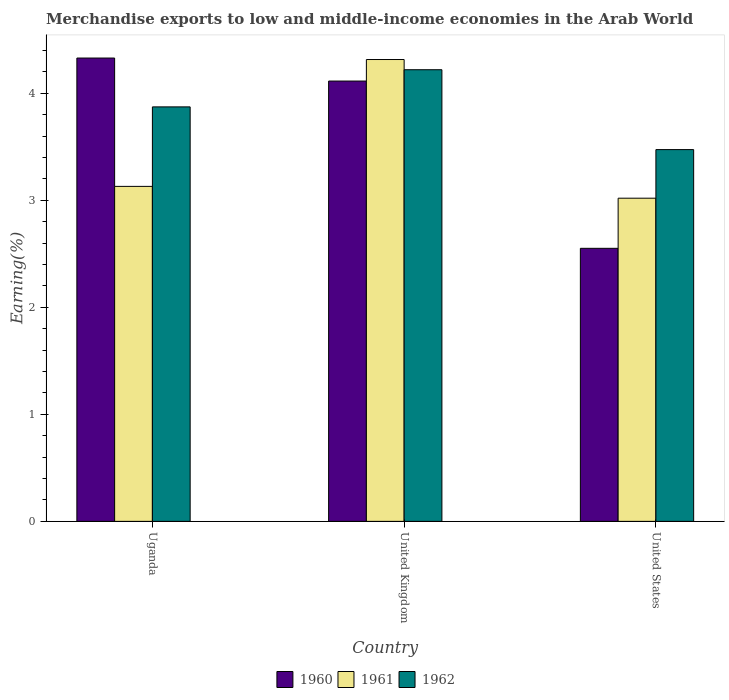How many groups of bars are there?
Give a very brief answer. 3. Are the number of bars per tick equal to the number of legend labels?
Your answer should be very brief. Yes. Are the number of bars on each tick of the X-axis equal?
Your response must be concise. Yes. How many bars are there on the 1st tick from the right?
Provide a succinct answer. 3. What is the label of the 1st group of bars from the left?
Offer a terse response. Uganda. What is the percentage of amount earned from merchandise exports in 1962 in United Kingdom?
Your answer should be compact. 4.22. Across all countries, what is the maximum percentage of amount earned from merchandise exports in 1962?
Ensure brevity in your answer.  4.22. Across all countries, what is the minimum percentage of amount earned from merchandise exports in 1962?
Give a very brief answer. 3.47. In which country was the percentage of amount earned from merchandise exports in 1960 minimum?
Your answer should be compact. United States. What is the total percentage of amount earned from merchandise exports in 1961 in the graph?
Ensure brevity in your answer.  10.47. What is the difference between the percentage of amount earned from merchandise exports in 1961 in Uganda and that in United Kingdom?
Ensure brevity in your answer.  -1.19. What is the difference between the percentage of amount earned from merchandise exports in 1961 in United States and the percentage of amount earned from merchandise exports in 1960 in United Kingdom?
Offer a very short reply. -1.09. What is the average percentage of amount earned from merchandise exports in 1961 per country?
Provide a short and direct response. 3.49. What is the difference between the percentage of amount earned from merchandise exports of/in 1962 and percentage of amount earned from merchandise exports of/in 1960 in United Kingdom?
Your response must be concise. 0.11. In how many countries, is the percentage of amount earned from merchandise exports in 1962 greater than 4.2 %?
Offer a very short reply. 1. What is the ratio of the percentage of amount earned from merchandise exports in 1962 in Uganda to that in United Kingdom?
Your answer should be very brief. 0.92. Is the percentage of amount earned from merchandise exports in 1962 in United Kingdom less than that in United States?
Keep it short and to the point. No. What is the difference between the highest and the second highest percentage of amount earned from merchandise exports in 1961?
Keep it short and to the point. -0.11. What is the difference between the highest and the lowest percentage of amount earned from merchandise exports in 1961?
Make the answer very short. 1.3. In how many countries, is the percentage of amount earned from merchandise exports in 1962 greater than the average percentage of amount earned from merchandise exports in 1962 taken over all countries?
Your response must be concise. 2. What does the 1st bar from the left in United Kingdom represents?
Your answer should be very brief. 1960. How many bars are there?
Your response must be concise. 9. Are all the bars in the graph horizontal?
Your answer should be very brief. No. How many countries are there in the graph?
Provide a short and direct response. 3. What is the difference between two consecutive major ticks on the Y-axis?
Give a very brief answer. 1. Are the values on the major ticks of Y-axis written in scientific E-notation?
Make the answer very short. No. How are the legend labels stacked?
Ensure brevity in your answer.  Horizontal. What is the title of the graph?
Offer a terse response. Merchandise exports to low and middle-income economies in the Arab World. Does "2000" appear as one of the legend labels in the graph?
Your answer should be compact. No. What is the label or title of the Y-axis?
Offer a terse response. Earning(%). What is the Earning(%) of 1960 in Uganda?
Offer a terse response. 4.33. What is the Earning(%) in 1961 in Uganda?
Keep it short and to the point. 3.13. What is the Earning(%) of 1962 in Uganda?
Keep it short and to the point. 3.87. What is the Earning(%) in 1960 in United Kingdom?
Offer a very short reply. 4.11. What is the Earning(%) in 1961 in United Kingdom?
Offer a terse response. 4.32. What is the Earning(%) in 1962 in United Kingdom?
Offer a terse response. 4.22. What is the Earning(%) in 1960 in United States?
Your answer should be compact. 2.55. What is the Earning(%) of 1961 in United States?
Offer a very short reply. 3.02. What is the Earning(%) of 1962 in United States?
Make the answer very short. 3.47. Across all countries, what is the maximum Earning(%) of 1960?
Give a very brief answer. 4.33. Across all countries, what is the maximum Earning(%) in 1961?
Make the answer very short. 4.32. Across all countries, what is the maximum Earning(%) in 1962?
Give a very brief answer. 4.22. Across all countries, what is the minimum Earning(%) in 1960?
Provide a succinct answer. 2.55. Across all countries, what is the minimum Earning(%) in 1961?
Offer a terse response. 3.02. Across all countries, what is the minimum Earning(%) of 1962?
Your answer should be compact. 3.47. What is the total Earning(%) of 1960 in the graph?
Your response must be concise. 11. What is the total Earning(%) in 1961 in the graph?
Make the answer very short. 10.47. What is the total Earning(%) in 1962 in the graph?
Ensure brevity in your answer.  11.57. What is the difference between the Earning(%) of 1960 in Uganda and that in United Kingdom?
Ensure brevity in your answer.  0.21. What is the difference between the Earning(%) of 1961 in Uganda and that in United Kingdom?
Offer a terse response. -1.19. What is the difference between the Earning(%) in 1962 in Uganda and that in United Kingdom?
Provide a short and direct response. -0.35. What is the difference between the Earning(%) in 1960 in Uganda and that in United States?
Your answer should be very brief. 1.78. What is the difference between the Earning(%) in 1961 in Uganda and that in United States?
Keep it short and to the point. 0.11. What is the difference between the Earning(%) in 1962 in Uganda and that in United States?
Keep it short and to the point. 0.4. What is the difference between the Earning(%) of 1960 in United Kingdom and that in United States?
Give a very brief answer. 1.56. What is the difference between the Earning(%) in 1961 in United Kingdom and that in United States?
Keep it short and to the point. 1.3. What is the difference between the Earning(%) in 1962 in United Kingdom and that in United States?
Provide a short and direct response. 0.75. What is the difference between the Earning(%) of 1960 in Uganda and the Earning(%) of 1961 in United Kingdom?
Your answer should be compact. 0.01. What is the difference between the Earning(%) of 1960 in Uganda and the Earning(%) of 1962 in United Kingdom?
Give a very brief answer. 0.11. What is the difference between the Earning(%) of 1961 in Uganda and the Earning(%) of 1962 in United Kingdom?
Provide a short and direct response. -1.09. What is the difference between the Earning(%) in 1960 in Uganda and the Earning(%) in 1961 in United States?
Provide a short and direct response. 1.31. What is the difference between the Earning(%) in 1960 in Uganda and the Earning(%) in 1962 in United States?
Ensure brevity in your answer.  0.86. What is the difference between the Earning(%) in 1961 in Uganda and the Earning(%) in 1962 in United States?
Offer a very short reply. -0.34. What is the difference between the Earning(%) of 1960 in United Kingdom and the Earning(%) of 1961 in United States?
Offer a terse response. 1.09. What is the difference between the Earning(%) of 1960 in United Kingdom and the Earning(%) of 1962 in United States?
Ensure brevity in your answer.  0.64. What is the difference between the Earning(%) in 1961 in United Kingdom and the Earning(%) in 1962 in United States?
Keep it short and to the point. 0.84. What is the average Earning(%) in 1960 per country?
Provide a short and direct response. 3.67. What is the average Earning(%) in 1961 per country?
Offer a very short reply. 3.49. What is the average Earning(%) in 1962 per country?
Offer a terse response. 3.86. What is the difference between the Earning(%) in 1960 and Earning(%) in 1961 in Uganda?
Your answer should be very brief. 1.2. What is the difference between the Earning(%) of 1960 and Earning(%) of 1962 in Uganda?
Provide a short and direct response. 0.46. What is the difference between the Earning(%) of 1961 and Earning(%) of 1962 in Uganda?
Your answer should be very brief. -0.74. What is the difference between the Earning(%) of 1960 and Earning(%) of 1961 in United Kingdom?
Give a very brief answer. -0.2. What is the difference between the Earning(%) in 1960 and Earning(%) in 1962 in United Kingdom?
Your answer should be very brief. -0.11. What is the difference between the Earning(%) in 1961 and Earning(%) in 1962 in United Kingdom?
Provide a short and direct response. 0.1. What is the difference between the Earning(%) in 1960 and Earning(%) in 1961 in United States?
Your answer should be very brief. -0.47. What is the difference between the Earning(%) in 1960 and Earning(%) in 1962 in United States?
Keep it short and to the point. -0.92. What is the difference between the Earning(%) in 1961 and Earning(%) in 1962 in United States?
Keep it short and to the point. -0.45. What is the ratio of the Earning(%) of 1960 in Uganda to that in United Kingdom?
Ensure brevity in your answer.  1.05. What is the ratio of the Earning(%) of 1961 in Uganda to that in United Kingdom?
Offer a very short reply. 0.73. What is the ratio of the Earning(%) in 1962 in Uganda to that in United Kingdom?
Your answer should be very brief. 0.92. What is the ratio of the Earning(%) of 1960 in Uganda to that in United States?
Provide a short and direct response. 1.7. What is the ratio of the Earning(%) of 1961 in Uganda to that in United States?
Offer a very short reply. 1.04. What is the ratio of the Earning(%) of 1962 in Uganda to that in United States?
Your answer should be compact. 1.11. What is the ratio of the Earning(%) of 1960 in United Kingdom to that in United States?
Your answer should be very brief. 1.61. What is the ratio of the Earning(%) in 1961 in United Kingdom to that in United States?
Make the answer very short. 1.43. What is the ratio of the Earning(%) of 1962 in United Kingdom to that in United States?
Offer a very short reply. 1.21. What is the difference between the highest and the second highest Earning(%) in 1960?
Offer a terse response. 0.21. What is the difference between the highest and the second highest Earning(%) of 1961?
Provide a succinct answer. 1.19. What is the difference between the highest and the second highest Earning(%) in 1962?
Provide a succinct answer. 0.35. What is the difference between the highest and the lowest Earning(%) in 1960?
Your answer should be very brief. 1.78. What is the difference between the highest and the lowest Earning(%) in 1961?
Offer a terse response. 1.3. What is the difference between the highest and the lowest Earning(%) of 1962?
Provide a short and direct response. 0.75. 